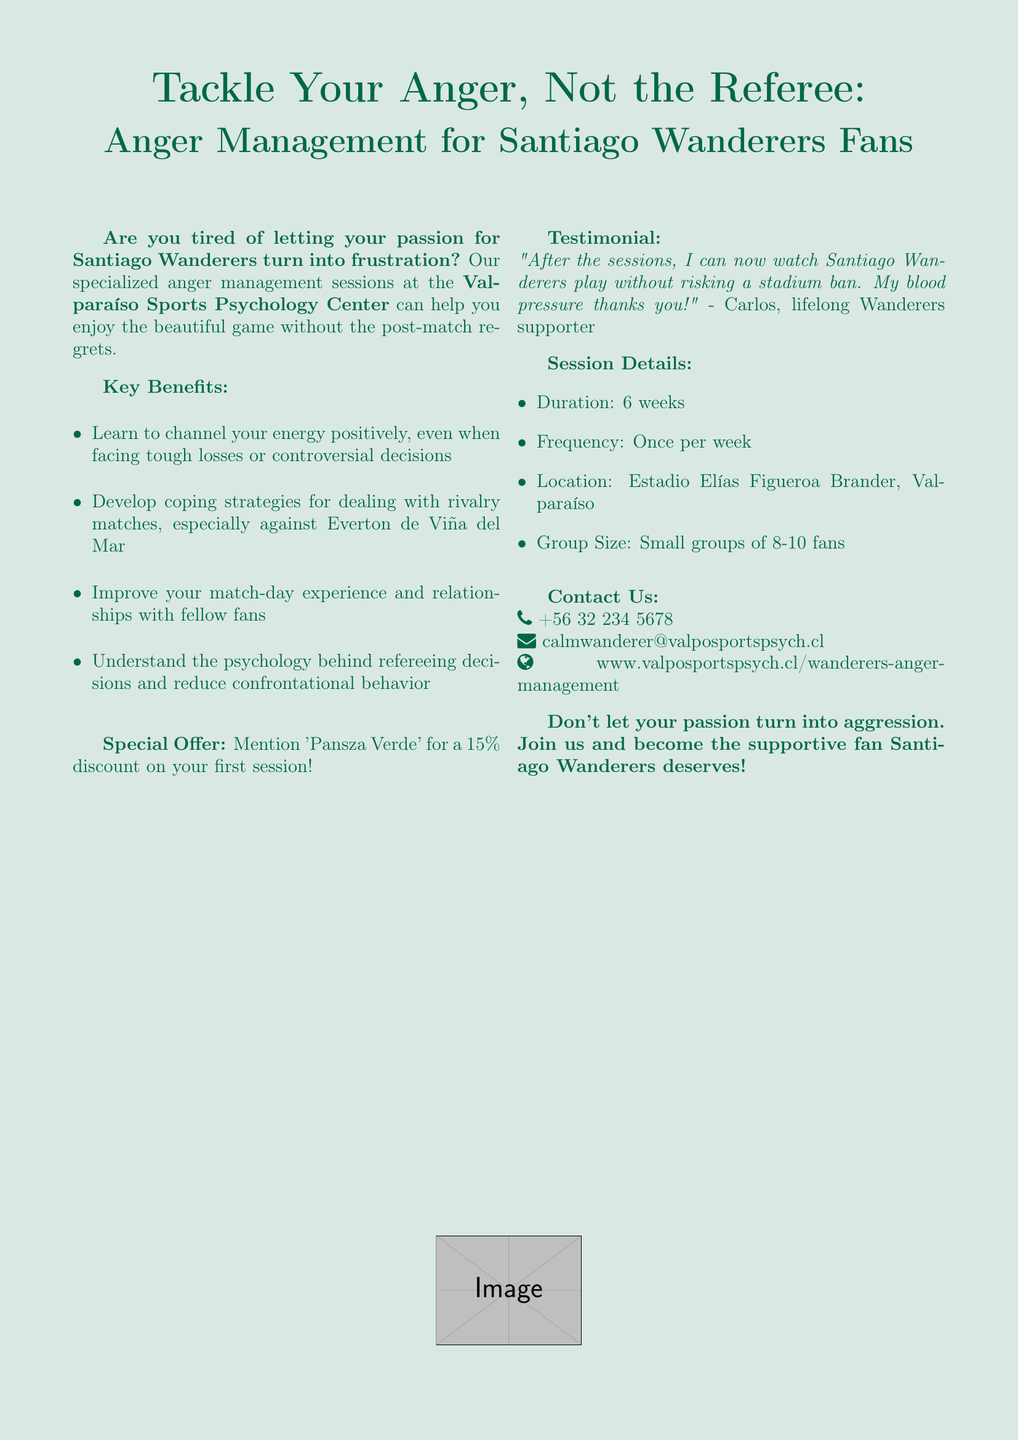What is the name of the clinic? The document mentions the clinic's name as Valparaíso Sports Psychology Center.
Answer: Valparaíso Sports Psychology Center How long is each session? The document states that the duration of the sessions is 6 weeks.
Answer: 6 weeks What special offer is mentioned? The document highlights a special offer where mentioning 'Pansza Verde' grants a 15% discount on the first session.
Answer: 15% discount What is the location of the sessions? According to the document, the sessions are held at Estadio Elías Figueroa Brander in Valparaíso.
Answer: Estadio Elías Figueroa Brander, Valparaíso How many fans are in each group? The document specifies that group sizes consist of 8-10 fans for the sessions.
Answer: 8-10 fans What main issue do these sessions aim to address? The introduction indicates that these sessions are designed to help fans manage their passion for Santiago Wanderers and reduce frustration.
Answer: Frustration Who provided a testimonial? The document includes a testimonial from a lifelong Wanderers supporter named Carlos.
Answer: Carlos What contact method is provided for inquiries? The document provides a phone number as a contact method, which is +56 32 234 5678.
Answer: +56 32 234 5678 